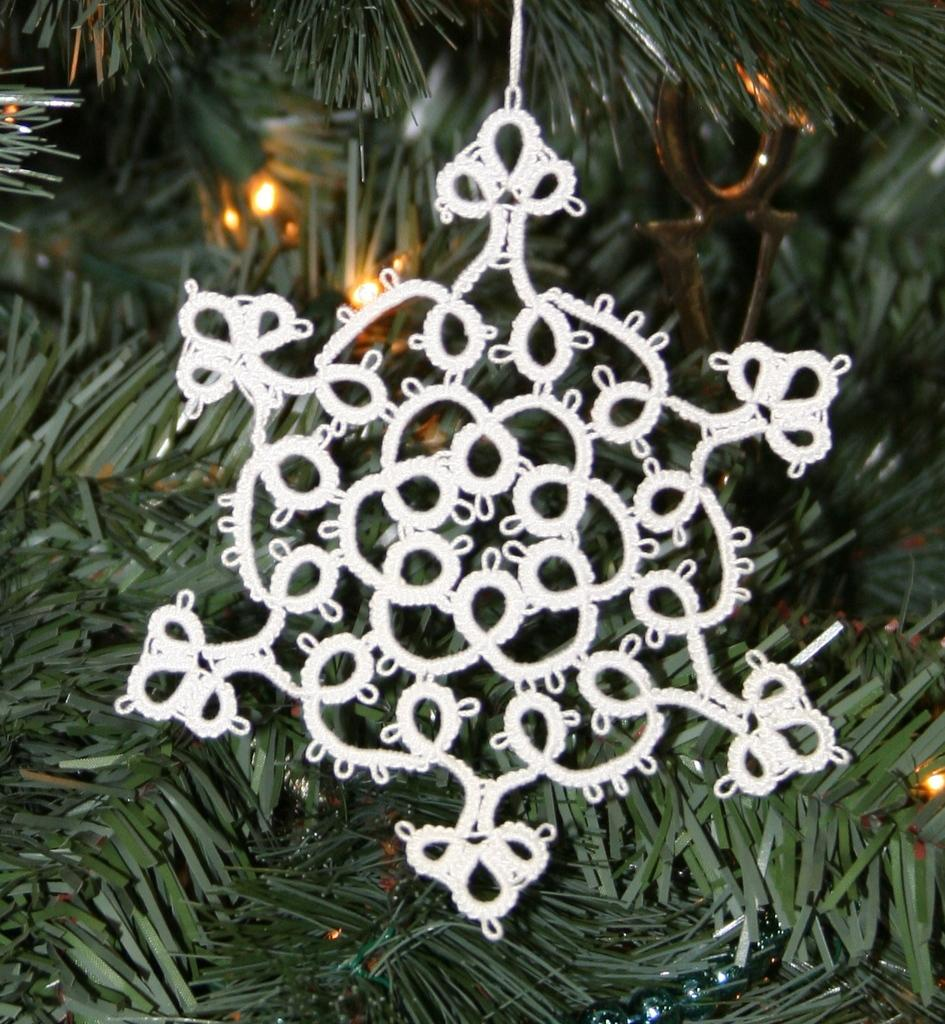What is the color of the decorative item in the image? The decorative item in the image is white. What type of natural elements can be seen in the image? There are leaves visible in the image. What type of artificial elements can be seen in the image? There are lights in the image. Can you provide an example of a sorting algorithm used in the image? There is no sorting algorithm present in the image, as it features a white decorative item, leaves, and lights. 